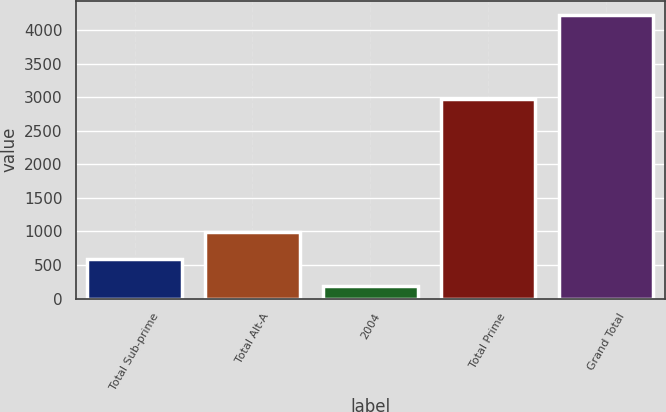Convert chart to OTSL. <chart><loc_0><loc_0><loc_500><loc_500><bar_chart><fcel>Total Sub-prime<fcel>Total Alt-A<fcel>2004<fcel>Total Prime<fcel>Grand Total<nl><fcel>592<fcel>996<fcel>188<fcel>2975<fcel>4228<nl></chart> 